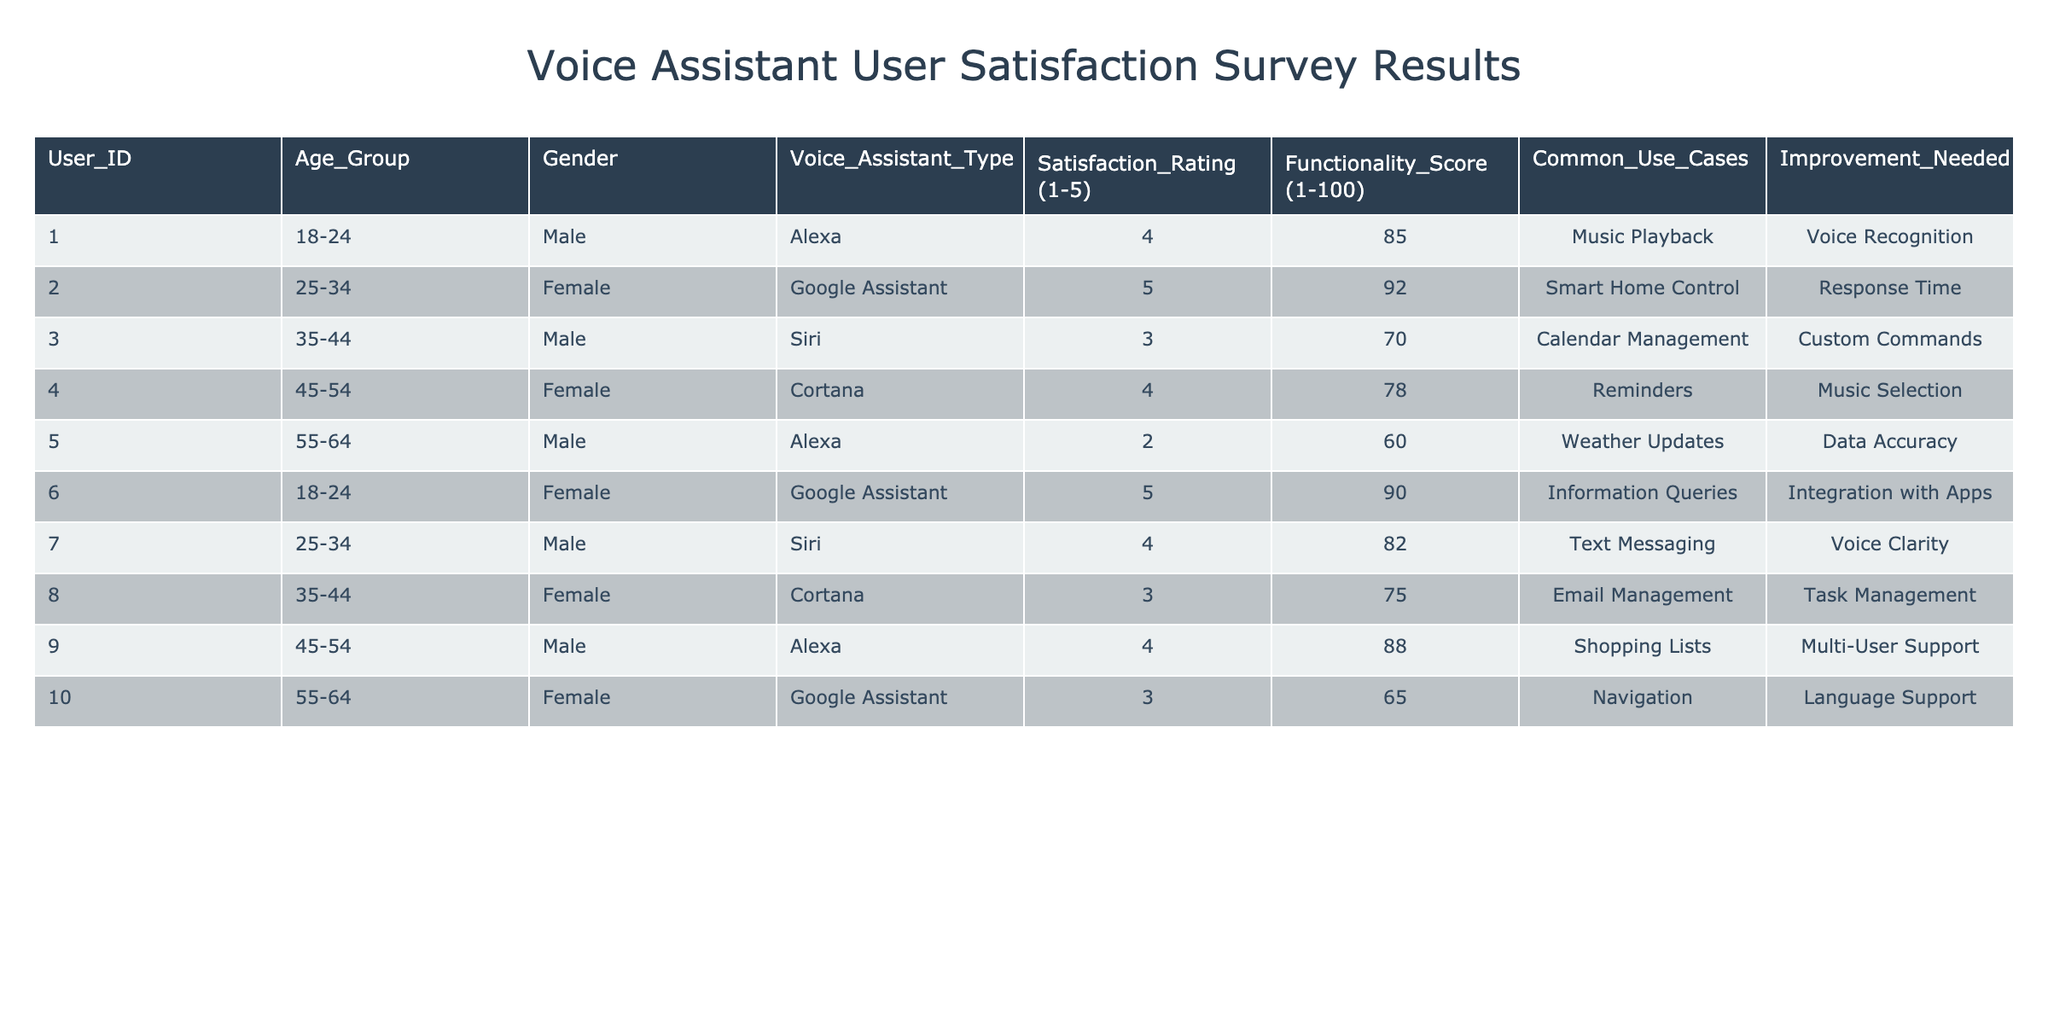What is the highest Satisfaction Rating in the table? The highest Satisfaction Rating is found by looking through the Satisfaction Rating column. The maximum value is 5, which appears for User_ID 002 and User_ID 006.
Answer: 5 Which Voice Assistant Type received the lowest Functionality Score? After reviewing the Functionality Score column, the lowest score is 60, associated with User_ID 005 using the Alexa assistant.
Answer: Alexa How many users reported needing improvement in Voice Recognition? To find the count of users needing improvement in Voice Recognition, we check the Improvement Needed column. Only User_ID 001 mentions this improvement, so the count is 1.
Answer: 1 What is the average Functionality Score for users aged 35-44? There are three users in the age group 35-44. Their Functionality Scores are 70, 75, and 88. The sum of these scores is 70 + 75 + 88 = 233. To get the average, we divide by 3: 233/3 = 77.67.
Answer: 77.67 Do any female users report a Satisfaction Rating of 5? Checking the Satisfaction Ratings of female users, only User_ID 002 and User_ID 006 report a rating of 5, thus confirming there are female users with a maximum satisfaction rating.
Answer: Yes What is the most common use case mentioned by users overall? We can identify the most common use case by analyzing the Common Use Cases column. "Voice Recognition" appears once, while "Music Playback," "Smart Home Control," and "Information Queries" also appear once. Hence, there is no single most common case.
Answer: No single most common case What is the difference in Functionality Scores between the highest and lowest rated Voice Assistant? The highest Functionality Score is for Google Assistant with 92, and the lowest is for Alexa with 60. The difference is 92 - 60 = 32.
Answer: 32 How many male users provided feedback on the Siri assistant? Looking at the data, there are two entries for Siri associated with male users, User_ID 003 and User_ID 007. Therefore, the count of feedback from male users using Siri is 2.
Answer: 2 Which age group reported the highest average Satisfaction Rating? We split the data by age groups: 18-24 has ratings of 4 and 5 (average 4.5), 25-34 has ratings of 5 and 4 (average 4.5), 35-44 has two ratings of 3 (average 3), 45-54 has ratings of 4 (average 4), and 55-64 has two ratings of 2 and 3 (average 2.5). The highest average is 4.5 for both the 18-24 and 25-34 age groups.
Answer: 18-24 and 25-34 